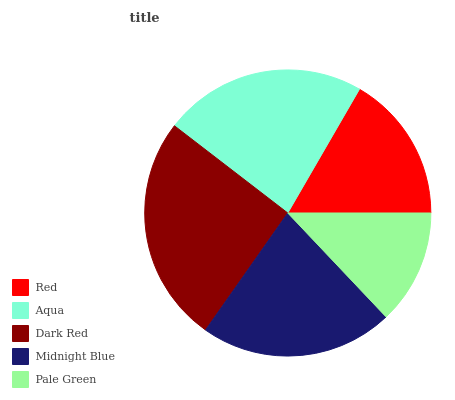Is Pale Green the minimum?
Answer yes or no. Yes. Is Dark Red the maximum?
Answer yes or no. Yes. Is Aqua the minimum?
Answer yes or no. No. Is Aqua the maximum?
Answer yes or no. No. Is Aqua greater than Red?
Answer yes or no. Yes. Is Red less than Aqua?
Answer yes or no. Yes. Is Red greater than Aqua?
Answer yes or no. No. Is Aqua less than Red?
Answer yes or no. No. Is Midnight Blue the high median?
Answer yes or no. Yes. Is Midnight Blue the low median?
Answer yes or no. Yes. Is Dark Red the high median?
Answer yes or no. No. Is Pale Green the low median?
Answer yes or no. No. 